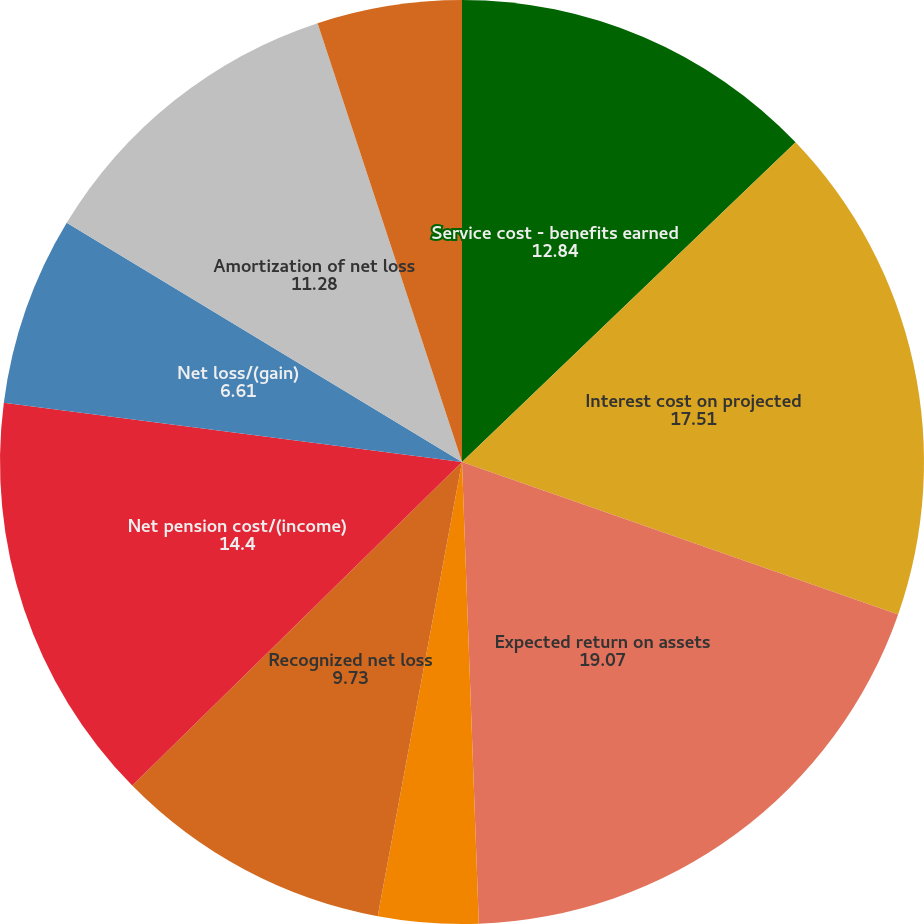Convert chart to OTSL. <chart><loc_0><loc_0><loc_500><loc_500><pie_chart><fcel>Service cost - benefits earned<fcel>Interest cost on projected<fcel>Expected return on assets<fcel>Amortization of prior service<fcel>Recognized net loss<fcel>Net pension cost/(income)<fcel>Net loss/(gain)<fcel>Amortization of net loss<fcel>Total<nl><fcel>12.84%<fcel>17.51%<fcel>19.07%<fcel>3.5%<fcel>9.73%<fcel>14.4%<fcel>6.61%<fcel>11.28%<fcel>5.06%<nl></chart> 